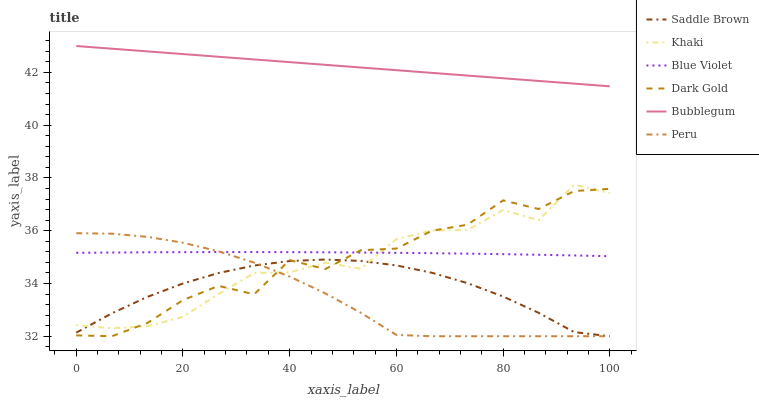Does Peru have the minimum area under the curve?
Answer yes or no. Yes. Does Bubblegum have the maximum area under the curve?
Answer yes or no. Yes. Does Dark Gold have the minimum area under the curve?
Answer yes or no. No. Does Dark Gold have the maximum area under the curve?
Answer yes or no. No. Is Bubblegum the smoothest?
Answer yes or no. Yes. Is Dark Gold the roughest?
Answer yes or no. Yes. Is Dark Gold the smoothest?
Answer yes or no. No. Is Bubblegum the roughest?
Answer yes or no. No. Does Dark Gold have the lowest value?
Answer yes or no. Yes. Does Bubblegum have the lowest value?
Answer yes or no. No. Does Bubblegum have the highest value?
Answer yes or no. Yes. Does Dark Gold have the highest value?
Answer yes or no. No. Is Saddle Brown less than Bubblegum?
Answer yes or no. Yes. Is Bubblegum greater than Dark Gold?
Answer yes or no. Yes. Does Dark Gold intersect Peru?
Answer yes or no. Yes. Is Dark Gold less than Peru?
Answer yes or no. No. Is Dark Gold greater than Peru?
Answer yes or no. No. Does Saddle Brown intersect Bubblegum?
Answer yes or no. No. 